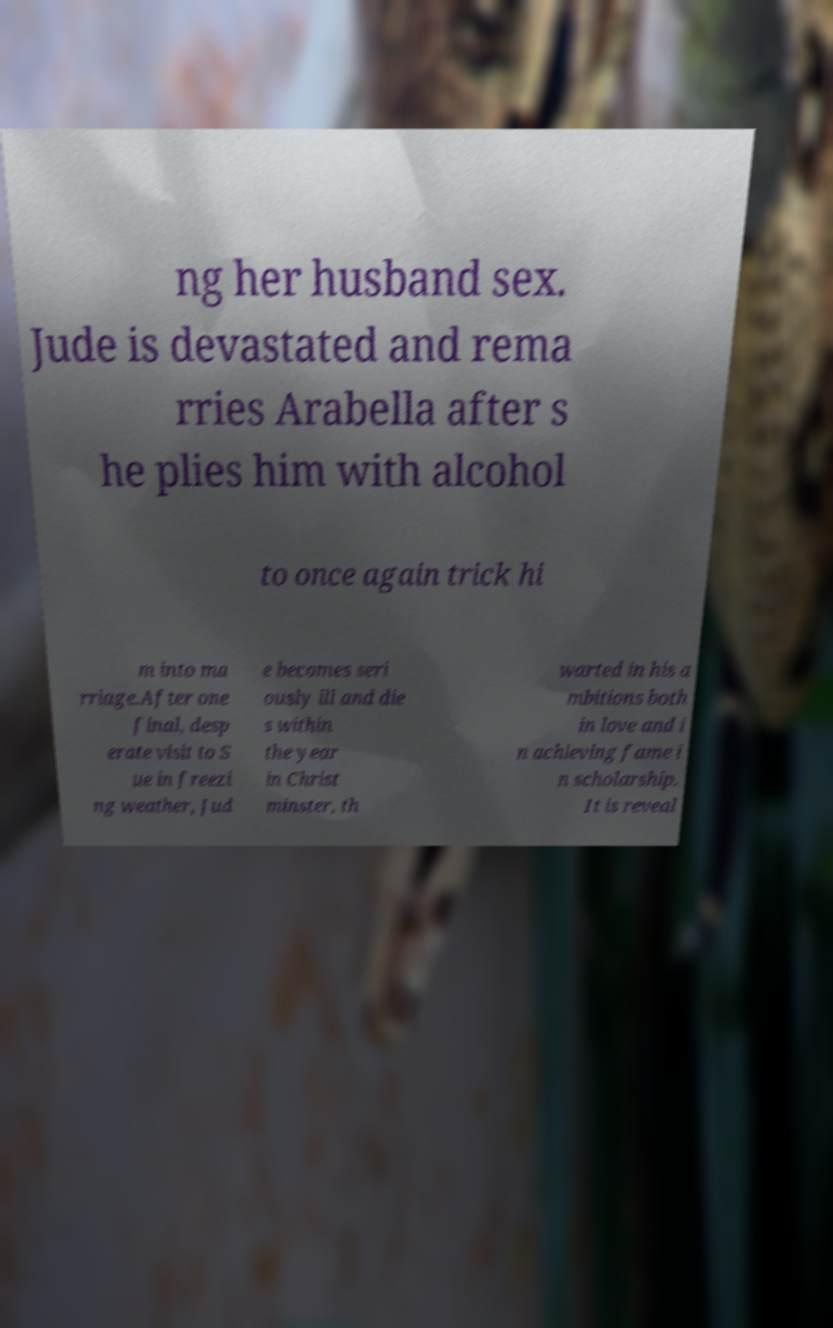Could you assist in decoding the text presented in this image and type it out clearly? ng her husband sex. Jude is devastated and rema rries Arabella after s he plies him with alcohol to once again trick hi m into ma rriage.After one final, desp erate visit to S ue in freezi ng weather, Jud e becomes seri ously ill and die s within the year in Christ minster, th warted in his a mbitions both in love and i n achieving fame i n scholarship. It is reveal 